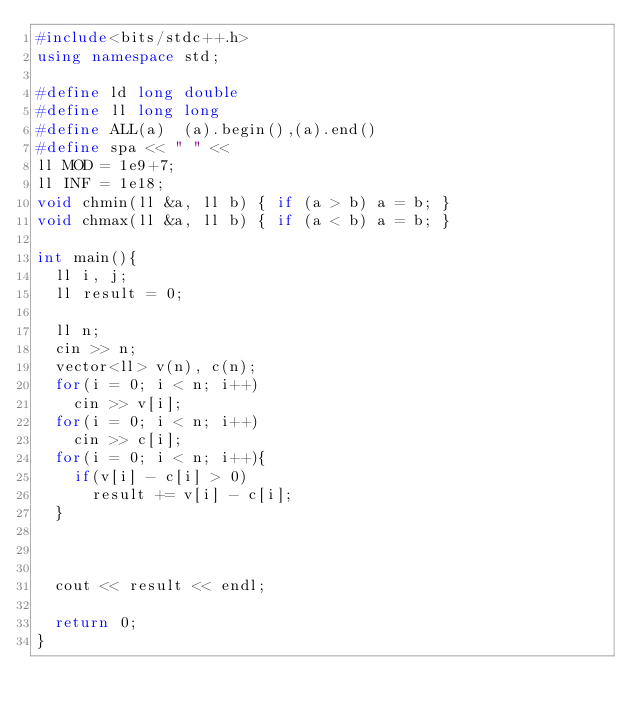Convert code to text. <code><loc_0><loc_0><loc_500><loc_500><_C++_>#include<bits/stdc++.h>
using namespace std;

#define ld long double
#define ll long long
#define ALL(a)  (a).begin(),(a).end()
#define spa << " " <<
ll MOD = 1e9+7;
ll INF = 1e18;
void chmin(ll &a, ll b) { if (a > b) a = b; }
void chmax(ll &a, ll b) { if (a < b) a = b; }

int main(){
  ll i, j;
  ll result = 0;
  
  ll n;
  cin >> n;
  vector<ll> v(n), c(n);
  for(i = 0; i < n; i++)
    cin >> v[i];
  for(i = 0; i < n; i++)
    cin >> c[i];
  for(i = 0; i < n; i++){
    if(v[i] - c[i] > 0)
      result += v[i] - c[i];
  }
    
    
    
  cout << result << endl;

  return 0;
}</code> 